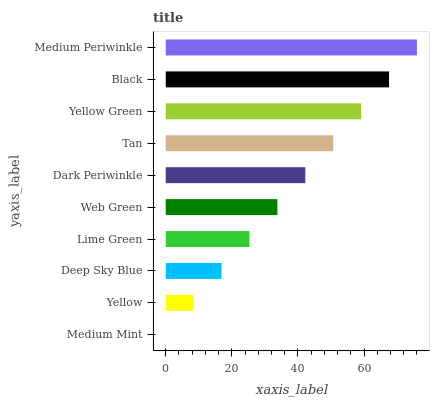Is Medium Mint the minimum?
Answer yes or no. Yes. Is Medium Periwinkle the maximum?
Answer yes or no. Yes. Is Yellow the minimum?
Answer yes or no. No. Is Yellow the maximum?
Answer yes or no. No. Is Yellow greater than Medium Mint?
Answer yes or no. Yes. Is Medium Mint less than Yellow?
Answer yes or no. Yes. Is Medium Mint greater than Yellow?
Answer yes or no. No. Is Yellow less than Medium Mint?
Answer yes or no. No. Is Dark Periwinkle the high median?
Answer yes or no. Yes. Is Web Green the low median?
Answer yes or no. Yes. Is Medium Mint the high median?
Answer yes or no. No. Is Dark Periwinkle the low median?
Answer yes or no. No. 